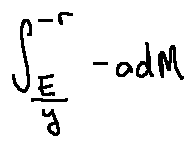<formula> <loc_0><loc_0><loc_500><loc_500>\int \lim i t s _ { \frac { E } { y } } ^ { - r } - o d M</formula> 